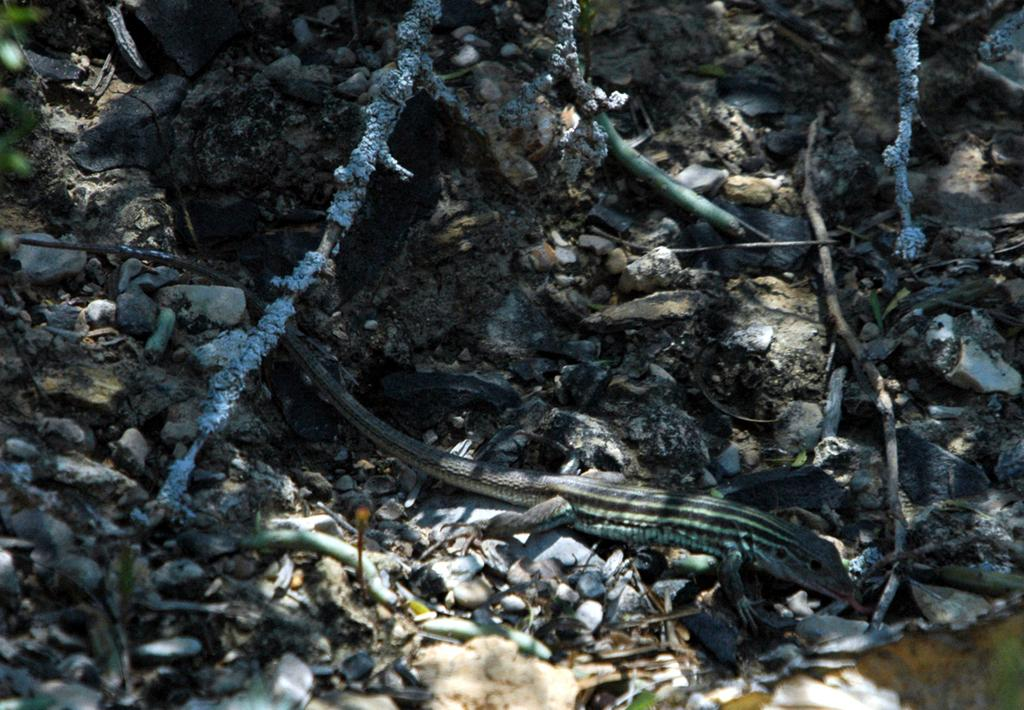What type of animal is in the image? There is a reptile in the image. What is the reptile doing in the image? The reptile is crawling on the ground. What can be seen in the background of the image? There are many stones in the image. What is the environment like around the reptile? There are dry items present around the reptile. How many kittens are playing with the yak in the image? There are no kittens or yak present in the image. What type of lace is draped over the reptile in the image? There is no lace present in the image; it is a reptile crawling on the ground with stones and dry items around it. 